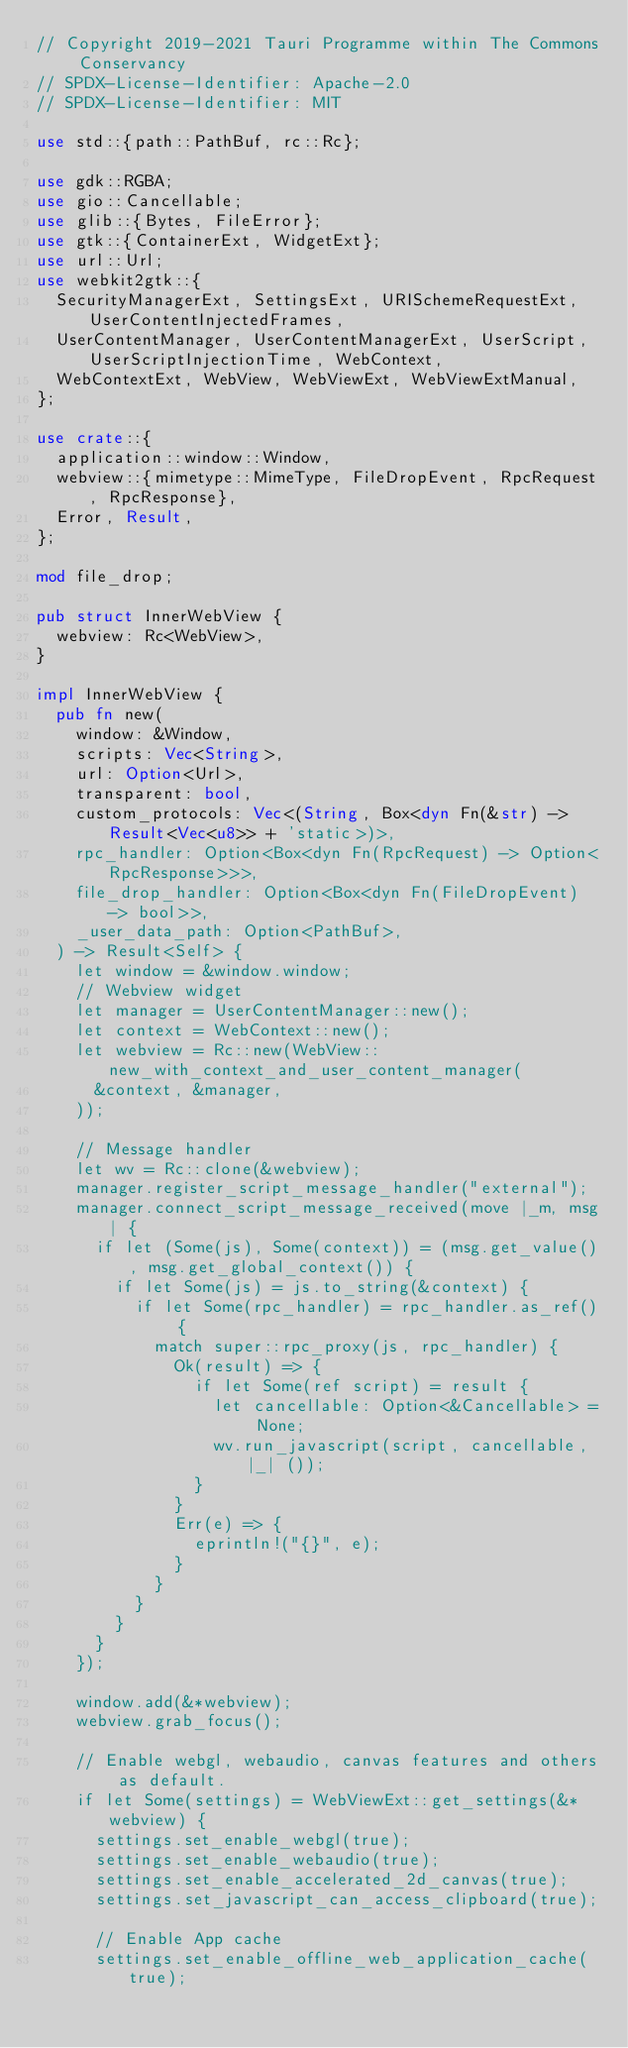Convert code to text. <code><loc_0><loc_0><loc_500><loc_500><_Rust_>// Copyright 2019-2021 Tauri Programme within The Commons Conservancy
// SPDX-License-Identifier: Apache-2.0
// SPDX-License-Identifier: MIT

use std::{path::PathBuf, rc::Rc};

use gdk::RGBA;
use gio::Cancellable;
use glib::{Bytes, FileError};
use gtk::{ContainerExt, WidgetExt};
use url::Url;
use webkit2gtk::{
  SecurityManagerExt, SettingsExt, URISchemeRequestExt, UserContentInjectedFrames,
  UserContentManager, UserContentManagerExt, UserScript, UserScriptInjectionTime, WebContext,
  WebContextExt, WebView, WebViewExt, WebViewExtManual,
};

use crate::{
  application::window::Window,
  webview::{mimetype::MimeType, FileDropEvent, RpcRequest, RpcResponse},
  Error, Result,
};

mod file_drop;

pub struct InnerWebView {
  webview: Rc<WebView>,
}

impl InnerWebView {
  pub fn new(
    window: &Window,
    scripts: Vec<String>,
    url: Option<Url>,
    transparent: bool,
    custom_protocols: Vec<(String, Box<dyn Fn(&str) -> Result<Vec<u8>> + 'static>)>,
    rpc_handler: Option<Box<dyn Fn(RpcRequest) -> Option<RpcResponse>>>,
    file_drop_handler: Option<Box<dyn Fn(FileDropEvent) -> bool>>,
    _user_data_path: Option<PathBuf>,
  ) -> Result<Self> {
    let window = &window.window;
    // Webview widget
    let manager = UserContentManager::new();
    let context = WebContext::new();
    let webview = Rc::new(WebView::new_with_context_and_user_content_manager(
      &context, &manager,
    ));

    // Message handler
    let wv = Rc::clone(&webview);
    manager.register_script_message_handler("external");
    manager.connect_script_message_received(move |_m, msg| {
      if let (Some(js), Some(context)) = (msg.get_value(), msg.get_global_context()) {
        if let Some(js) = js.to_string(&context) {
          if let Some(rpc_handler) = rpc_handler.as_ref() {
            match super::rpc_proxy(js, rpc_handler) {
              Ok(result) => {
                if let Some(ref script) = result {
                  let cancellable: Option<&Cancellable> = None;
                  wv.run_javascript(script, cancellable, |_| ());
                }
              }
              Err(e) => {
                eprintln!("{}", e);
              }
            }
          }
        }
      }
    });

    window.add(&*webview);
    webview.grab_focus();

    // Enable webgl, webaudio, canvas features and others as default.
    if let Some(settings) = WebViewExt::get_settings(&*webview) {
      settings.set_enable_webgl(true);
      settings.set_enable_webaudio(true);
      settings.set_enable_accelerated_2d_canvas(true);
      settings.set_javascript_can_access_clipboard(true);

      // Enable App cache
      settings.set_enable_offline_web_application_cache(true);</code> 